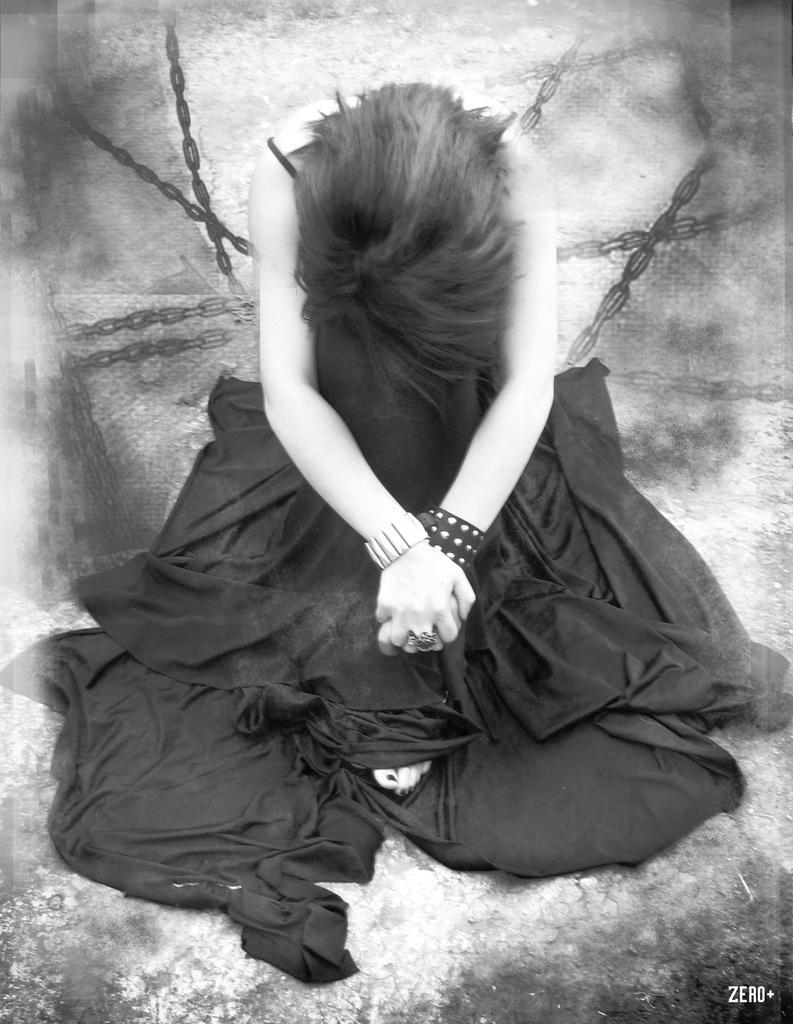Could you give a brief overview of what you see in this image? Here in this picture we can see a woman in black colored dress sitting on the ground and we can see chains present behind her. 